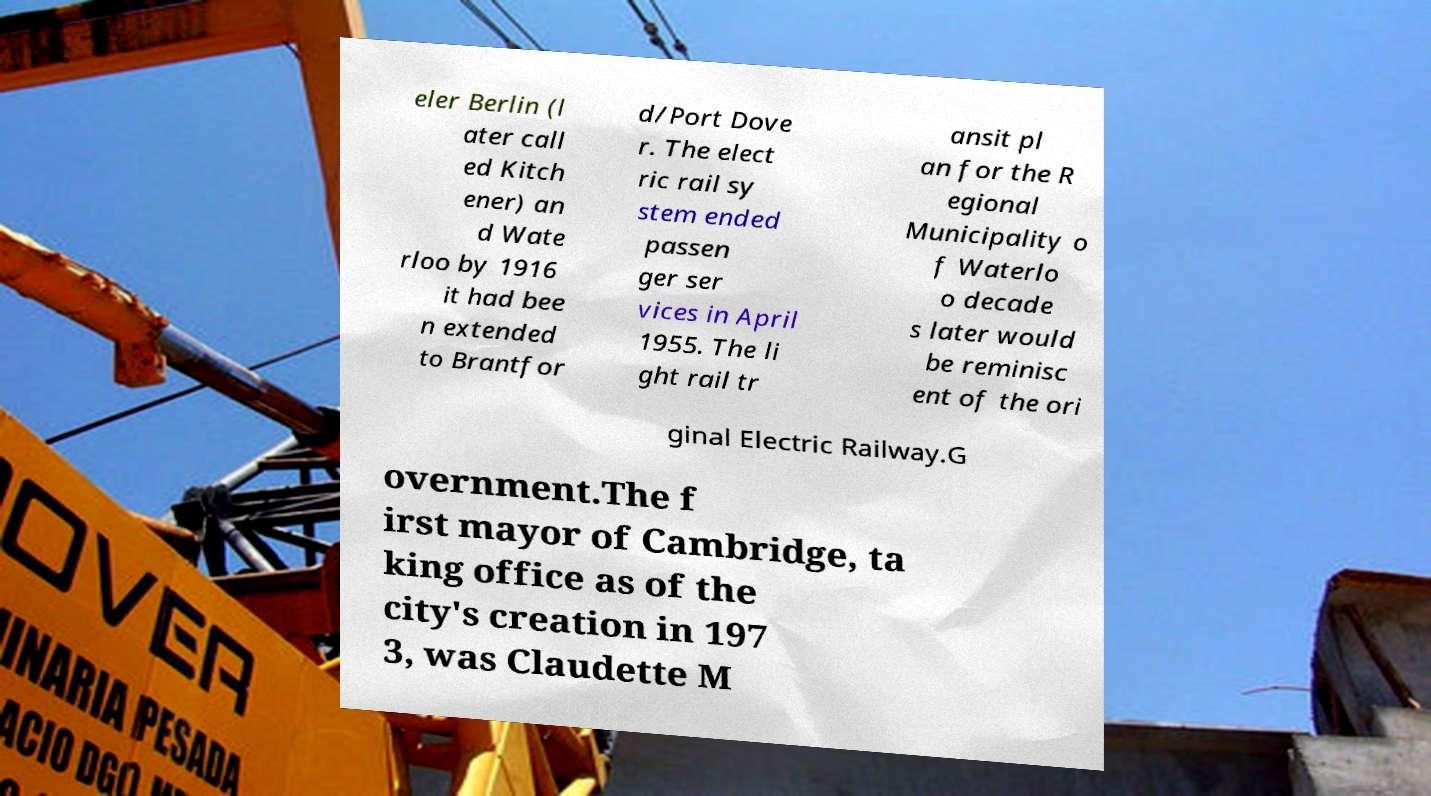Can you accurately transcribe the text from the provided image for me? eler Berlin (l ater call ed Kitch ener) an d Wate rloo by 1916 it had bee n extended to Brantfor d/Port Dove r. The elect ric rail sy stem ended passen ger ser vices in April 1955. The li ght rail tr ansit pl an for the R egional Municipality o f Waterlo o decade s later would be reminisc ent of the ori ginal Electric Railway.G overnment.The f irst mayor of Cambridge, ta king office as of the city's creation in 197 3, was Claudette M 